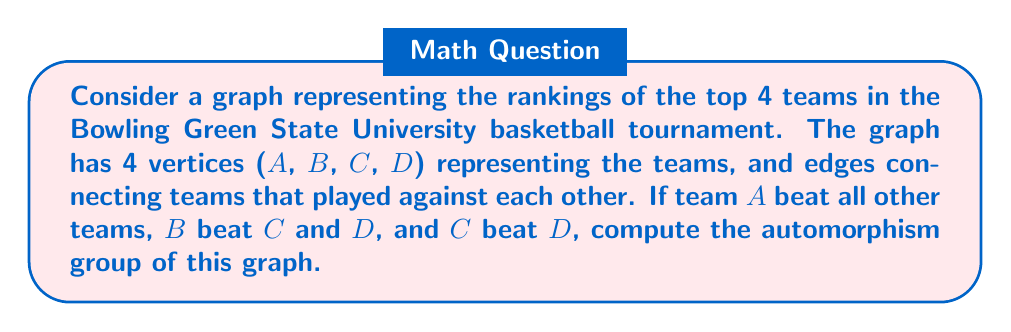What is the answer to this math problem? Let's approach this step-by-step:

1) First, let's visualize the graph:

[asy]
import graph;
size(200);
vertex[] G = graph(4);
G[0].label="A";
G[1].label="B";
G[2].label="C";
G[3].label="D";
draw(G[0]--G[1]--G[2]--G[3]);
draw(G[0]--G[2], G[0]--G[3], G[1]--G[3]);
[/asy]

2) To find the automorphism group, we need to identify all symmetries of this graph.

3) Looking at the graph, we can see that:
   - A is connected to all other vertices (degree 3)
   - B is connected to A, C, and D (degree 3)
   - C is connected to A, B, and D (degree 3)
   - D is connected to A, B, and C (degree 1)

4) The only possible automorphism would be swapping B and C, as they have the same degree and connections.

5) Therefore, the automorphism group consists of two permutations:
   - The identity permutation: $(A)(B)(C)(D)$
   - The permutation that swaps B and C: $(A)(BC)(D)$

6) This group is isomorphic to the cyclic group of order 2, $C_2$ or $\mathbb{Z}_2$.

7) In cycle notation, the automorphism group is $\{(A)(B)(C)(D), (A)(BC)(D)\}$.

8) The order of this group is 2.
Answer: The automorphism group of the given graph is isomorphic to $C_2$ or $\mathbb{Z}_2$, with elements $\{(A)(B)(C)(D), (A)(BC)(D)\}$ in cycle notation. The order of the group is 2. 